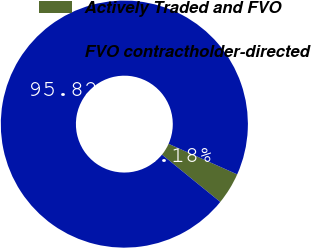Convert chart to OTSL. <chart><loc_0><loc_0><loc_500><loc_500><pie_chart><fcel>Actively Traded and FVO<fcel>FVO contractholder-directed<nl><fcel>4.18%<fcel>95.82%<nl></chart> 